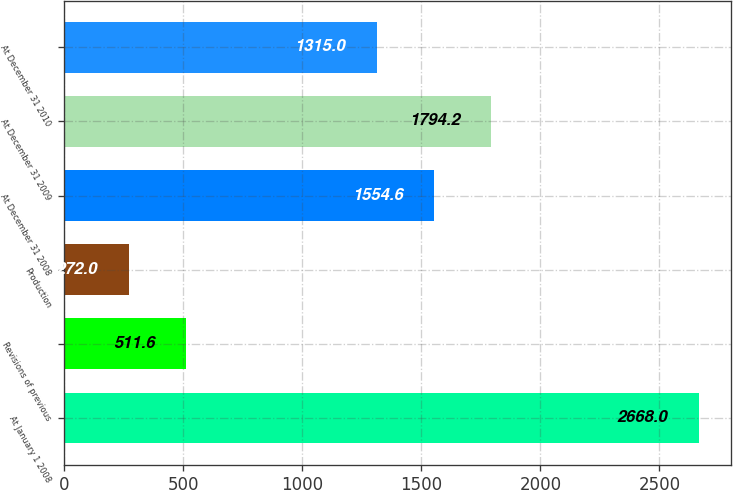Convert chart. <chart><loc_0><loc_0><loc_500><loc_500><bar_chart><fcel>At January 1 2008<fcel>Revisions of previous<fcel>Production<fcel>At December 31 2008<fcel>At December 31 2009<fcel>At December 31 2010<nl><fcel>2668<fcel>511.6<fcel>272<fcel>1554.6<fcel>1794.2<fcel>1315<nl></chart> 